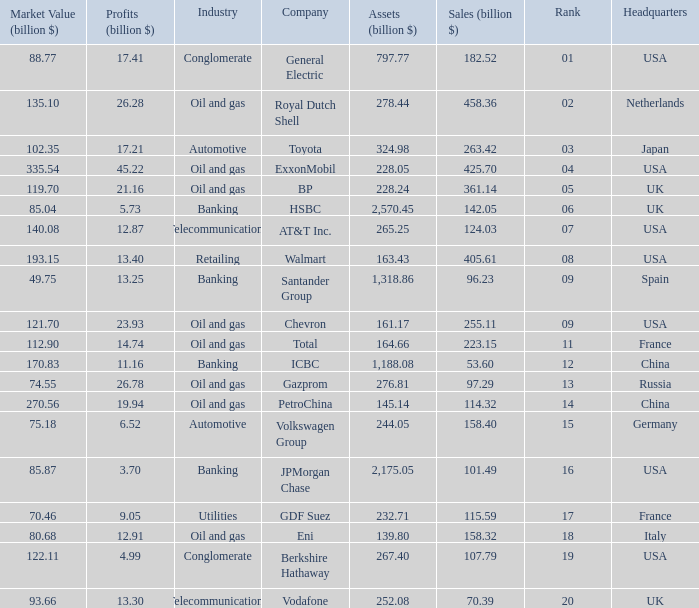How many Assets (billion $) has an Industry of oil and gas, and a Rank of 9, and a Market Value (billion $) larger than 121.7? None. 